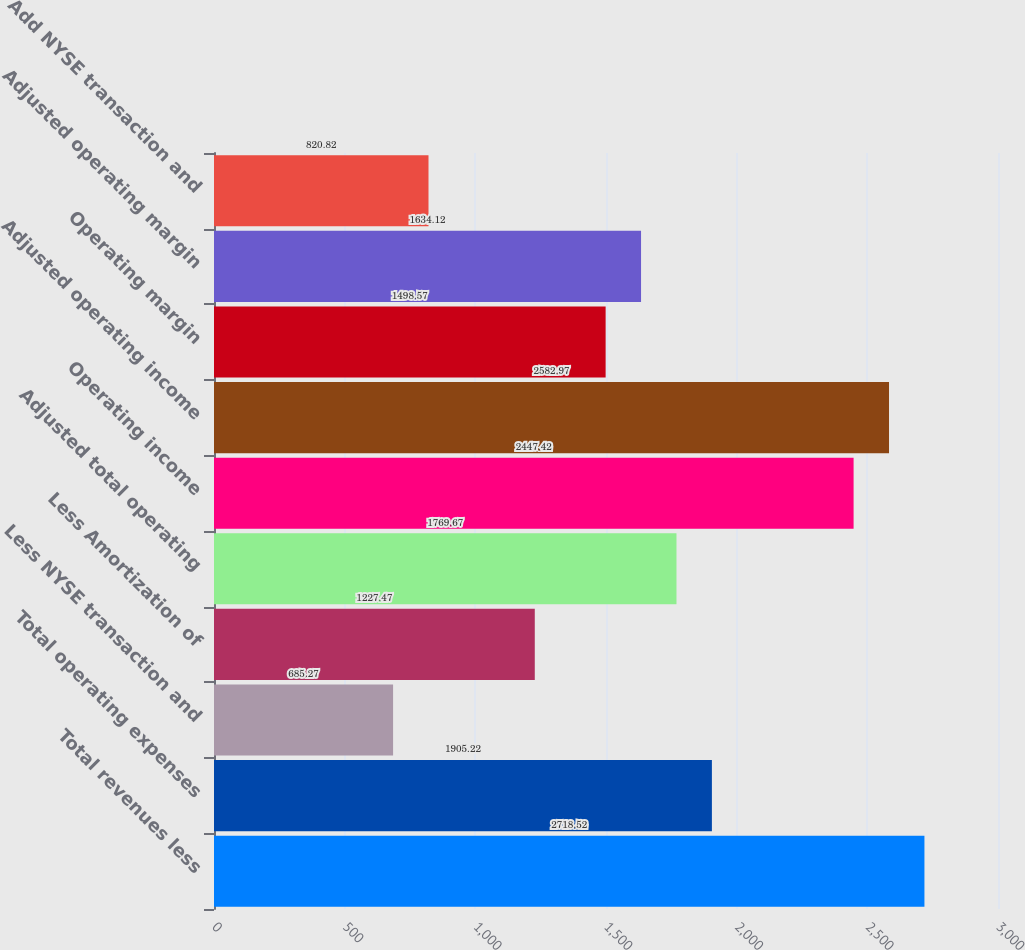Convert chart. <chart><loc_0><loc_0><loc_500><loc_500><bar_chart><fcel>Total revenues less<fcel>Total operating expenses<fcel>Less NYSE transaction and<fcel>Less Amortization of<fcel>Adjusted total operating<fcel>Operating income<fcel>Adjusted operating income<fcel>Operating margin<fcel>Adjusted operating margin<fcel>Add NYSE transaction and<nl><fcel>2718.52<fcel>1905.22<fcel>685.27<fcel>1227.47<fcel>1769.67<fcel>2447.42<fcel>2582.97<fcel>1498.57<fcel>1634.12<fcel>820.82<nl></chart> 